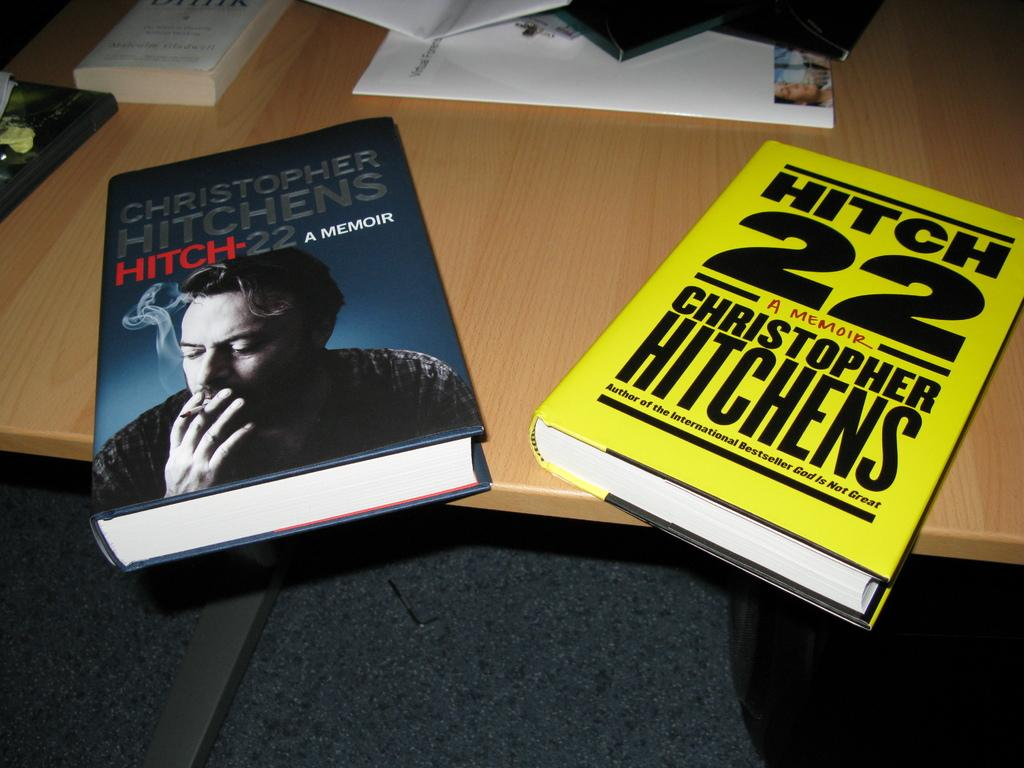<image>
Create a compact narrative representing the image presented. Two books from the author Christopher Hitchens are on the table. 